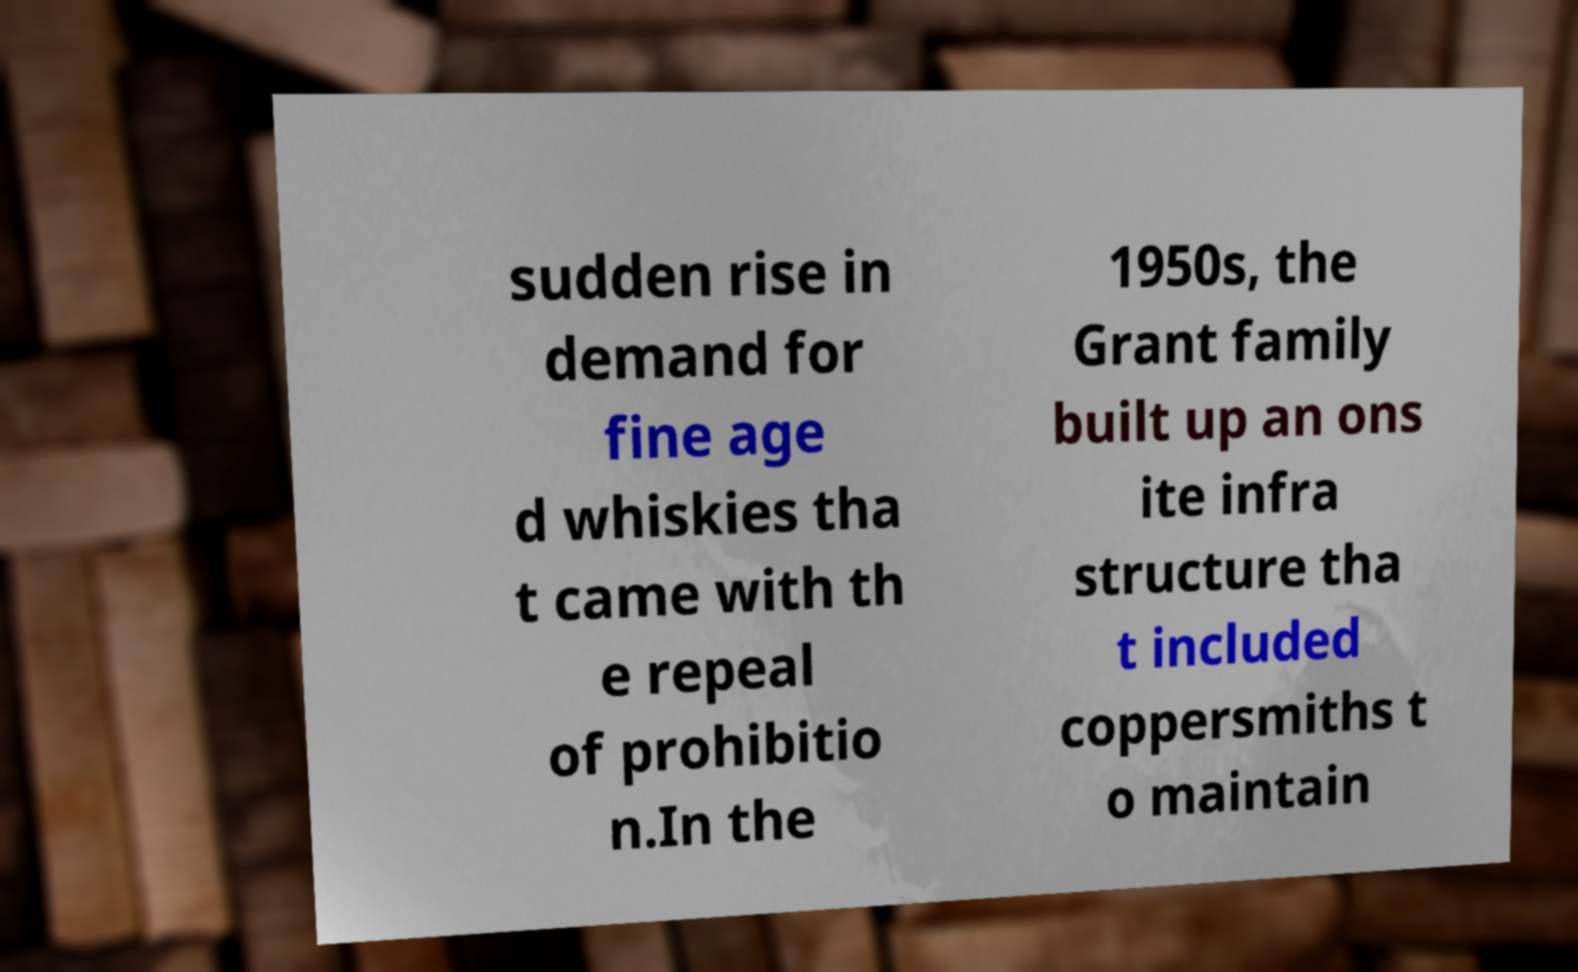For documentation purposes, I need the text within this image transcribed. Could you provide that? sudden rise in demand for fine age d whiskies tha t came with th e repeal of prohibitio n.In the 1950s, the Grant family built up an ons ite infra structure tha t included coppersmiths t o maintain 